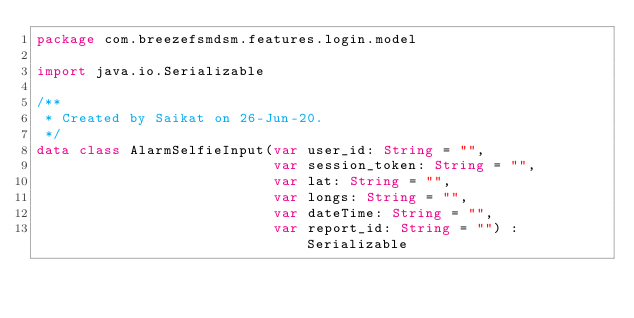<code> <loc_0><loc_0><loc_500><loc_500><_Kotlin_>package com.breezefsmdsm.features.login.model

import java.io.Serializable

/**
 * Created by Saikat on 26-Jun-20.
 */
data class AlarmSelfieInput(var user_id: String = "",
                            var session_token: String = "",
                            var lat: String = "",
                            var longs: String = "",
                            var dateTime: String = "",
                            var report_id: String = "") : Serializable</code> 